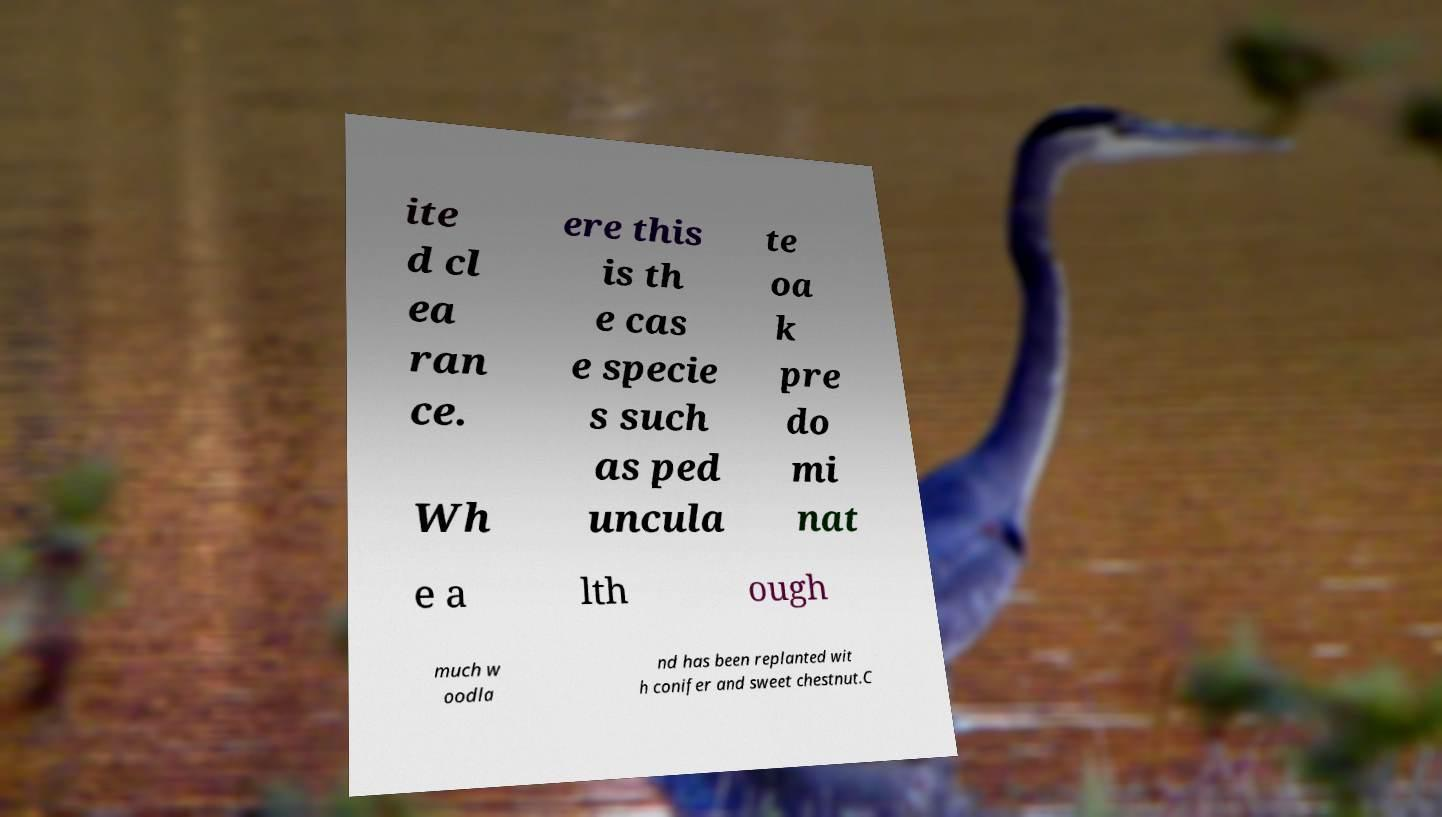Could you extract and type out the text from this image? ite d cl ea ran ce. Wh ere this is th e cas e specie s such as ped uncula te oa k pre do mi nat e a lth ough much w oodla nd has been replanted wit h conifer and sweet chestnut.C 